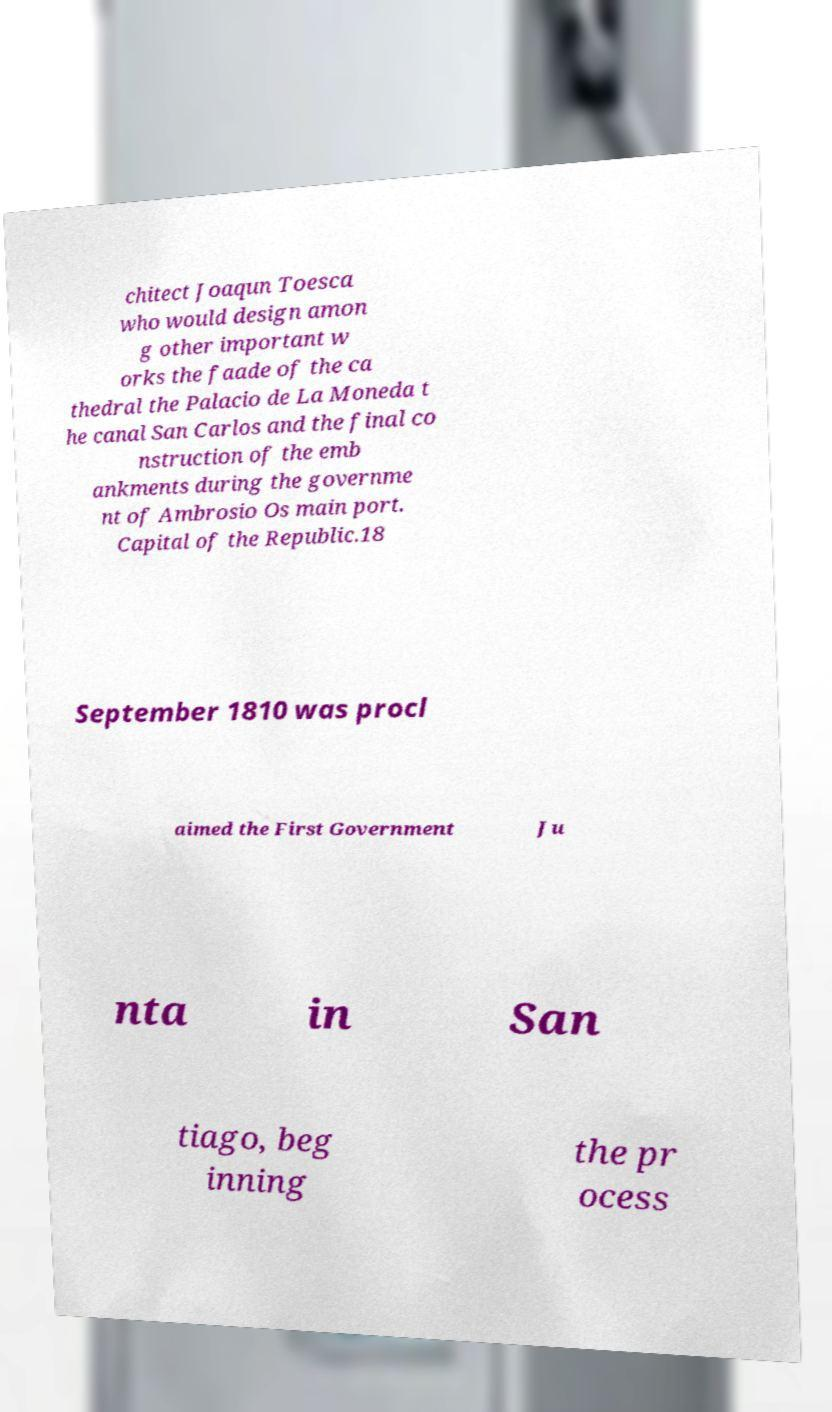Could you assist in decoding the text presented in this image and type it out clearly? chitect Joaqun Toesca who would design amon g other important w orks the faade of the ca thedral the Palacio de La Moneda t he canal San Carlos and the final co nstruction of the emb ankments during the governme nt of Ambrosio Os main port. Capital of the Republic.18 September 1810 was procl aimed the First Government Ju nta in San tiago, beg inning the pr ocess 